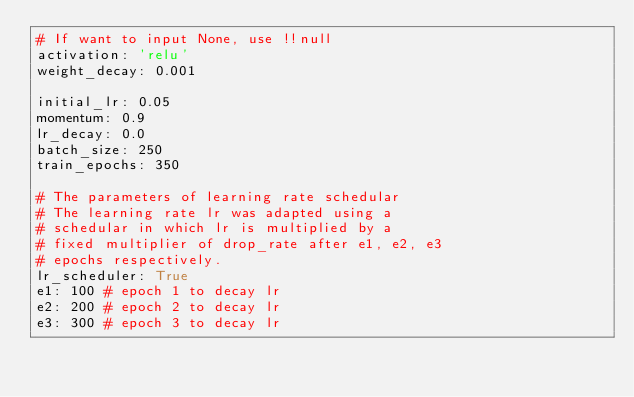<code> <loc_0><loc_0><loc_500><loc_500><_YAML_># If want to input None, use !!null
activation: 'relu'
weight_decay: 0.001

initial_lr: 0.05
momentum: 0.9
lr_decay: 0.0
batch_size: 250
train_epochs: 350

# The parameters of learning rate schedular
# The learning rate lr was adapted using a 
# schedular in which lr is multiplied by a 
# fixed multiplier of drop_rate after e1, e2, e3
# epochs respectively.
lr_scheduler: True
e1: 100 # epoch 1 to decay lr
e2: 200 # epoch 2 to decay lr
e3: 300 # epoch 3 to decay lr
</code> 